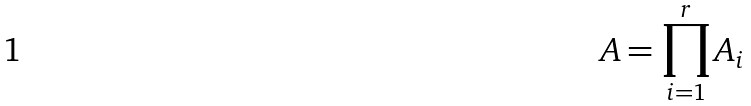<formula> <loc_0><loc_0><loc_500><loc_500>A = \prod _ { i = 1 } ^ { r } A _ { i }</formula> 